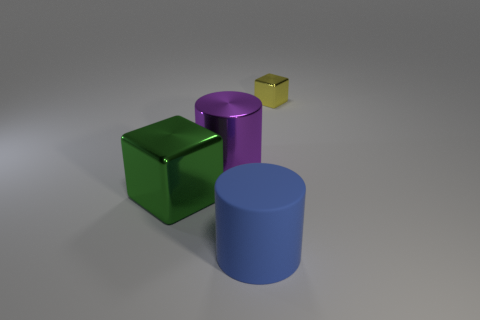Is there anything else that has the same size as the yellow object?
Offer a very short reply. No. Is the number of things that are behind the large purple metal cylinder less than the number of metallic objects that are right of the big green object?
Your answer should be very brief. Yes. What number of other objects are the same shape as the yellow metallic thing?
Keep it short and to the point. 1. There is a cube that is right of the shiny block on the left side of the thing that is behind the big purple object; what is its size?
Ensure brevity in your answer.  Small. How many red things are either tiny blocks or shiny cylinders?
Provide a succinct answer. 0. There is a big object behind the metallic cube that is in front of the small thing; what is its shape?
Your response must be concise. Cylinder. Does the cube to the left of the large purple shiny thing have the same size as the block that is right of the green thing?
Your response must be concise. No. Are there any big objects that have the same material as the tiny yellow cube?
Provide a short and direct response. Yes. Are there any small yellow objects in front of the shiny cube that is left of the metal cube that is right of the blue cylinder?
Give a very brief answer. No. There is a green metal block; are there any green shiny blocks on the right side of it?
Your answer should be very brief. No. 